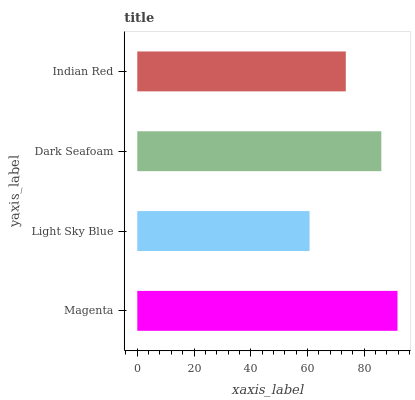Is Light Sky Blue the minimum?
Answer yes or no. Yes. Is Magenta the maximum?
Answer yes or no. Yes. Is Dark Seafoam the minimum?
Answer yes or no. No. Is Dark Seafoam the maximum?
Answer yes or no. No. Is Dark Seafoam greater than Light Sky Blue?
Answer yes or no. Yes. Is Light Sky Blue less than Dark Seafoam?
Answer yes or no. Yes. Is Light Sky Blue greater than Dark Seafoam?
Answer yes or no. No. Is Dark Seafoam less than Light Sky Blue?
Answer yes or no. No. Is Dark Seafoam the high median?
Answer yes or no. Yes. Is Indian Red the low median?
Answer yes or no. Yes. Is Light Sky Blue the high median?
Answer yes or no. No. Is Dark Seafoam the low median?
Answer yes or no. No. 